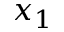<formula> <loc_0><loc_0><loc_500><loc_500>x _ { 1 }</formula> 